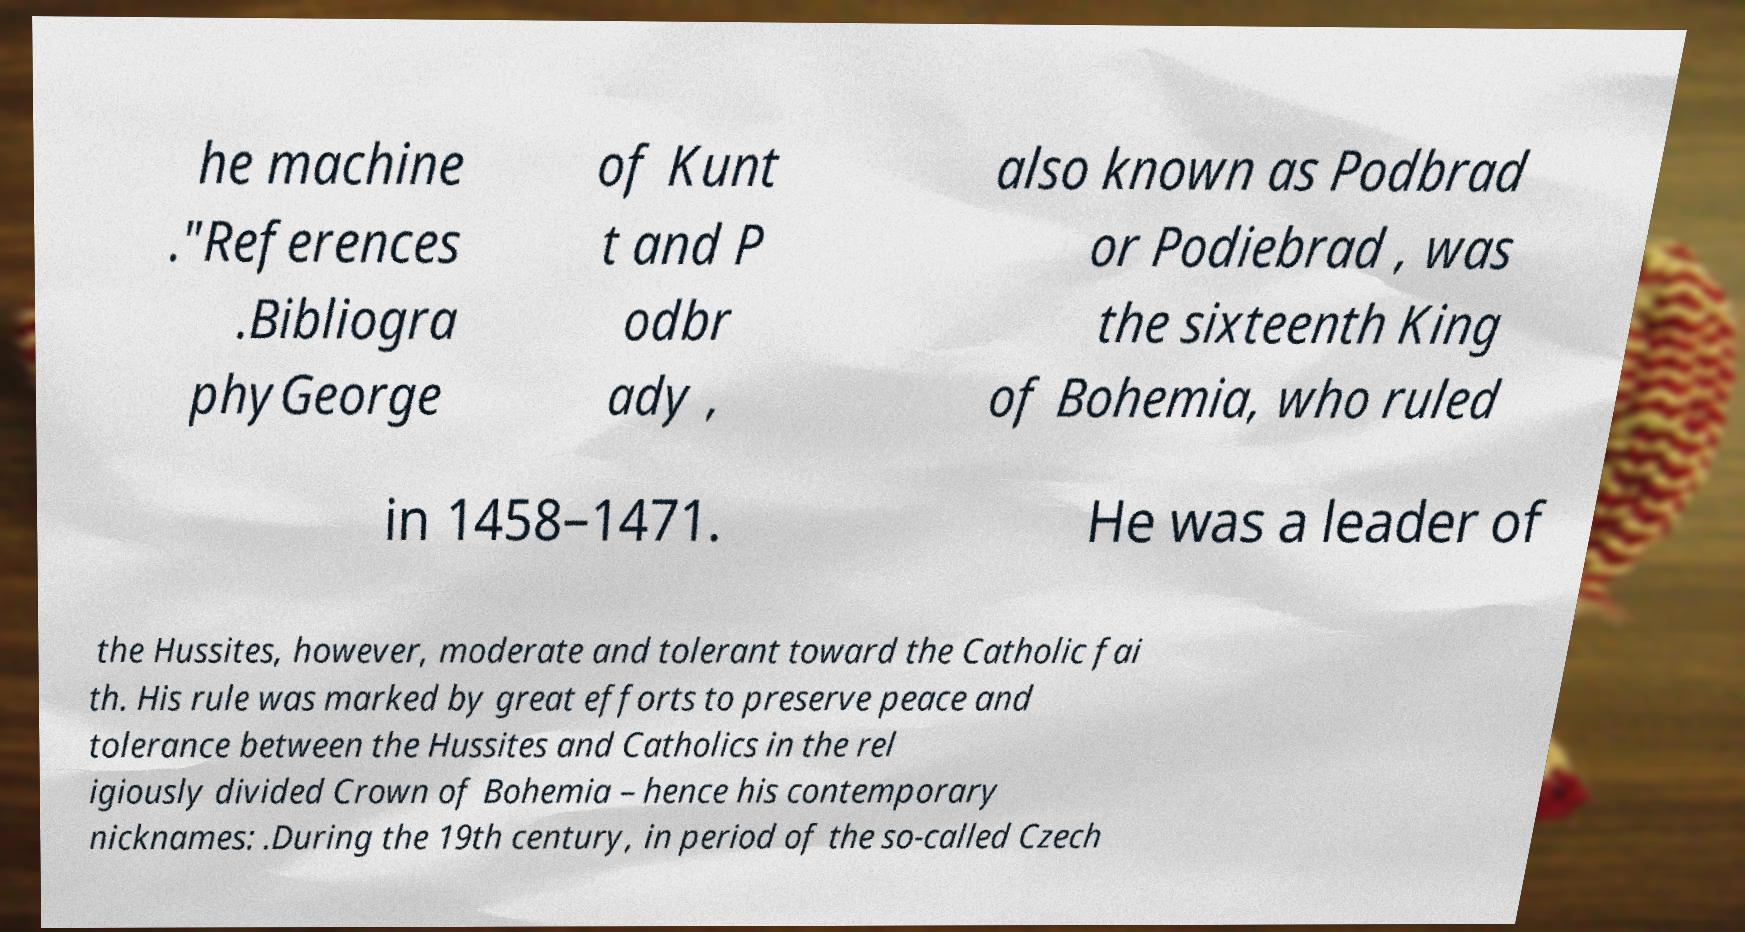Can you accurately transcribe the text from the provided image for me? he machine ."References .Bibliogra phyGeorge of Kunt t and P odbr ady , also known as Podbrad or Podiebrad , was the sixteenth King of Bohemia, who ruled in 1458–1471. He was a leader of the Hussites, however, moderate and tolerant toward the Catholic fai th. His rule was marked by great efforts to preserve peace and tolerance between the Hussites and Catholics in the rel igiously divided Crown of Bohemia – hence his contemporary nicknames: .During the 19th century, in period of the so-called Czech 